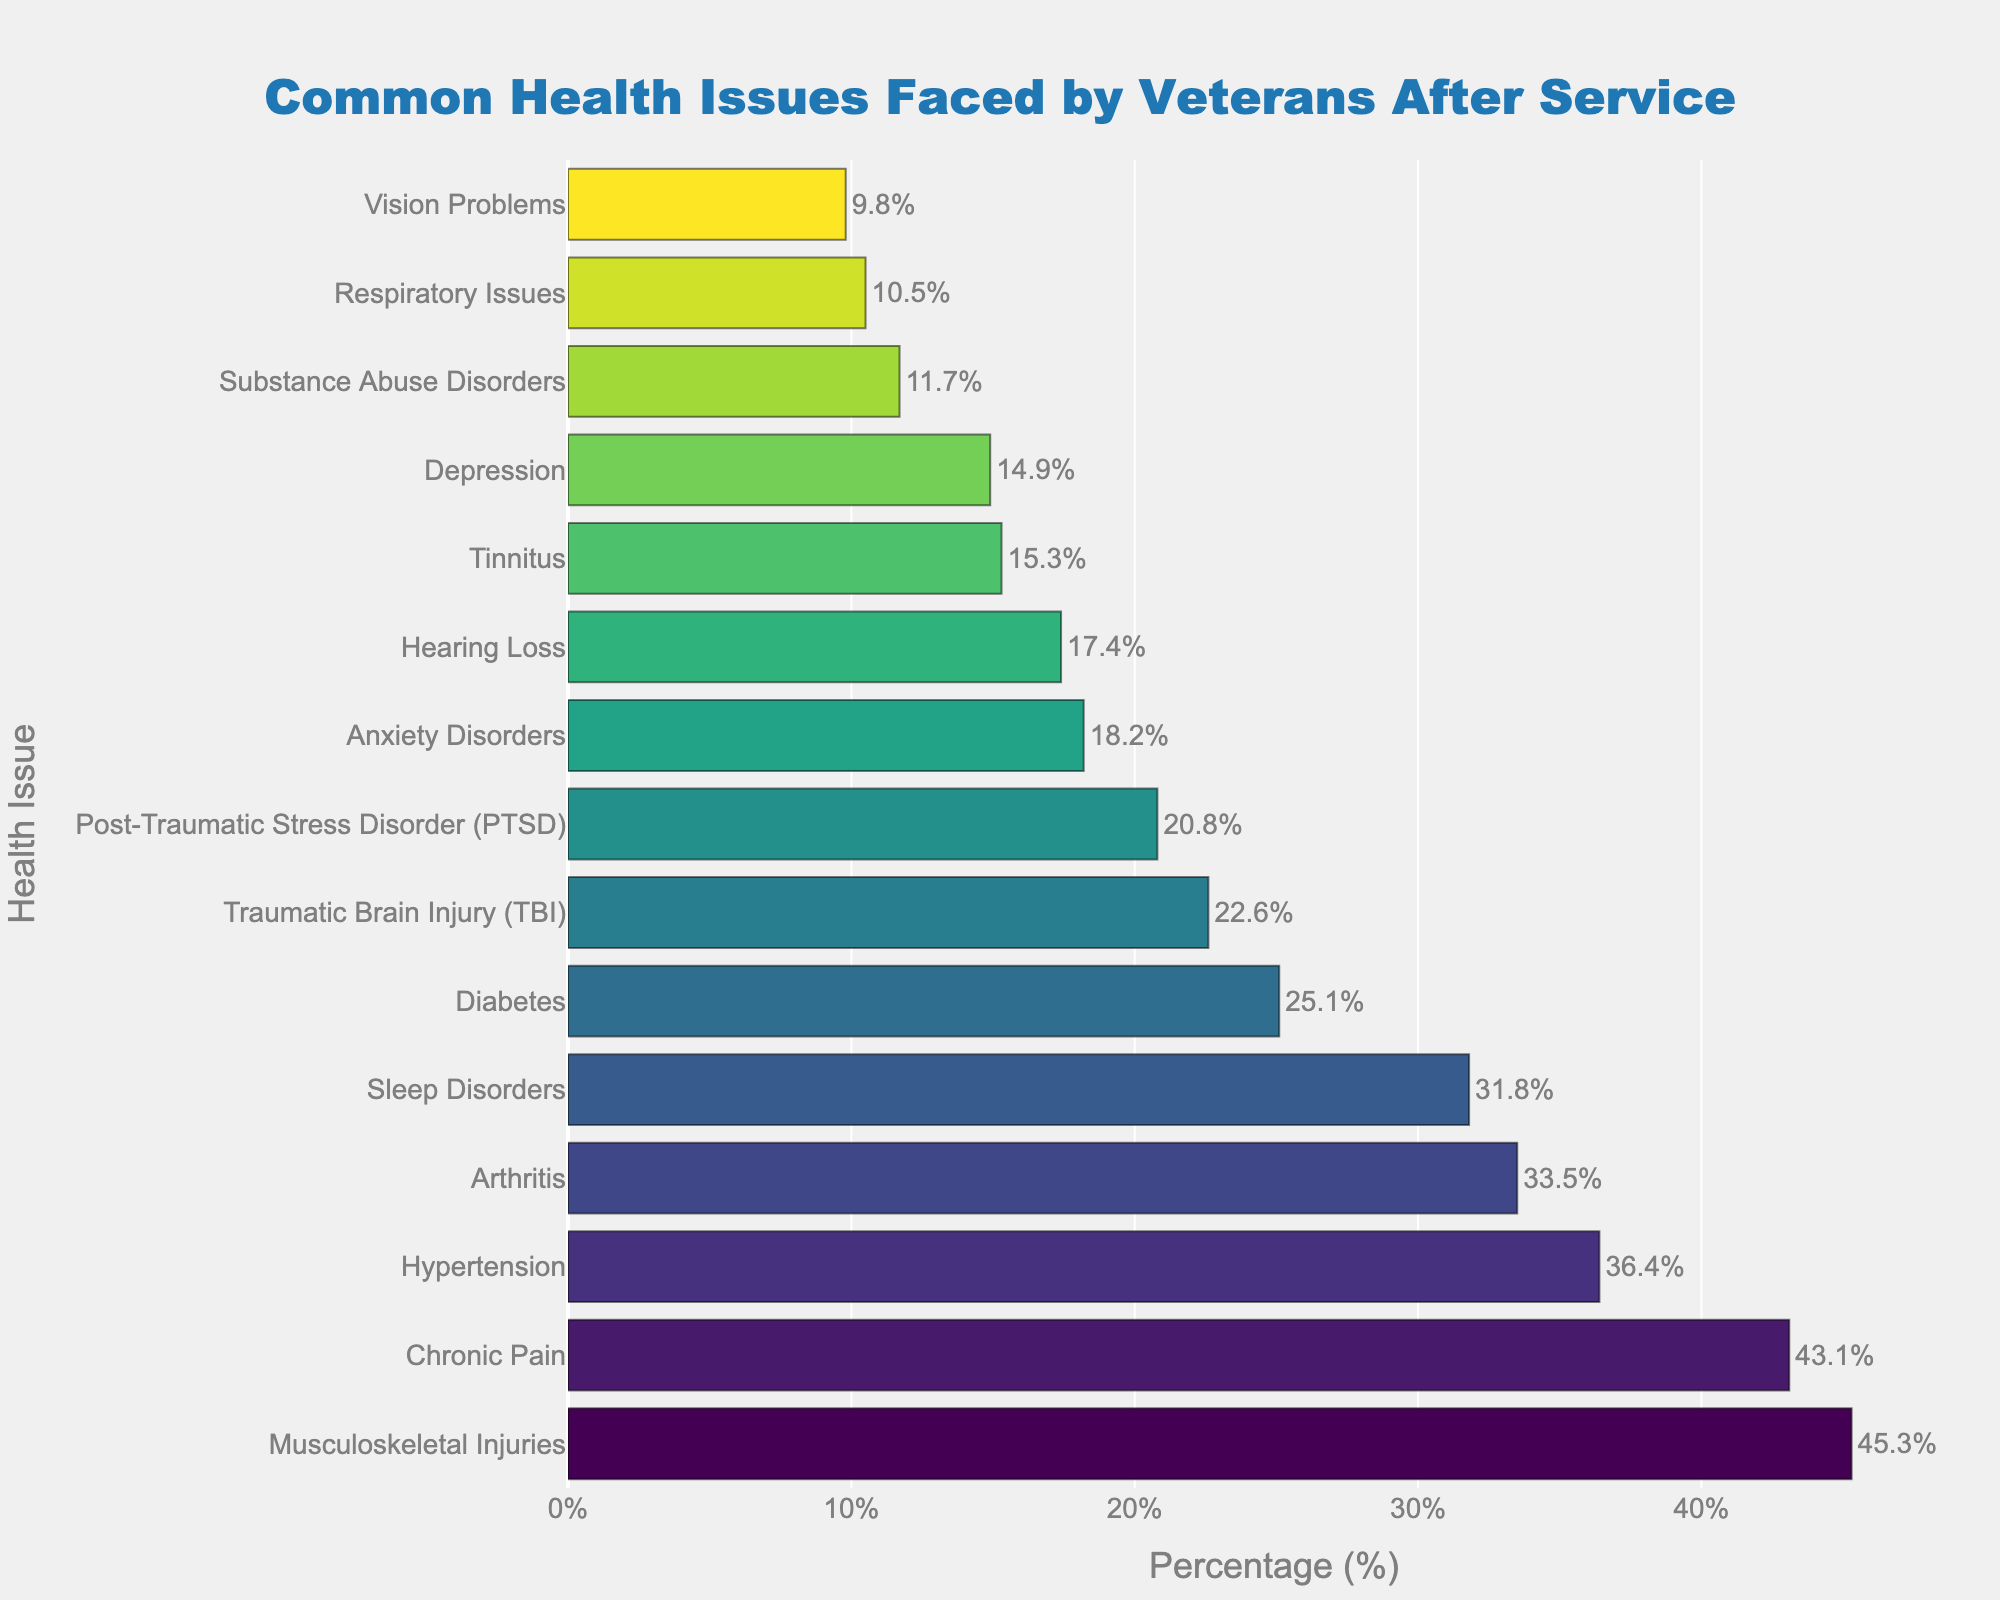Which health issue faced by veterans has the highest percentage? By visually inspecting the figure, the bar corresponding to "Musculoskeletal Injuries" is the longest, indicating it has the highest percentage.
Answer: Musculoskeletal Injuries What is the combined percentage of veterans facing Post-Traumatic Stress Disorder (PTSD) and Traumatic Brain Injury (TBI)? Sum the percentages of PTSD (20.8%) and TBI (22.6%). The combined percentage is 20.8 + 22.6 = 43.4%.
Answer: 43.4% Which health issue is more prevalent, Hypertension or Diabetes? By comparing the lengths of the bars, the bar corresponding to Hypertension is longer than the bar for Diabetes.
Answer: Hypertension List three health issues with a percentage higher than 30%. Visually inspect the figure and identify the bars. The health issues are Musculoskeletal Injuries (45.3%), Chronic Pain (43.1%), and Hypertension (36.4%).
Answer: Musculoskeletal Injuries, Chronic Pain, Hypertension What is the percentage difference between Substance Abuse Disorders and Sleep Disorders? Subtract the percentage of Substance Abuse Disorders (11.7%) from Sleep Disorders (31.8%). The difference is 31.8 - 11.7 = 20.1%.
Answer: 20.1% Which health issue has the smallest percentage and what is it? The bar corresponding to Vision Problems is the shortest, indicating it has the smallest percentage. The percentage is 9.8%.
Answer: Vision Problems, 9.8% Are Anxiety Disorders more or less common than Depression among veterans? By comparing the lengths of the bars, the bar corresponding to Depression is longer than the bar for Anxiety Disorders.
Answer: Less common How does the percentage of veterans with Arthritis compare to those with Diabetes? By inspecting the figure, the bar for Arthritis is shorter than the bar for Diabetes.
Answer: Less What is the average percentage of the top three health issues? Add the percentages of the top three issues: Musculoskeletal Injuries (45.3%), Chronic Pain (43.1%), and Hypertension (36.4%). Then divide by 3: (45.3 + 43.1 + 36.4) / 3 = 41.6%.
Answer: 41.6% Which category falls right in the middle of the sorted list by percentage, and what is the percentage? With 15 categories, the middle one is the 8th when sorted. "Sleep Disorders" is the 8th bar after sorting, with a percentage of 31.8%.
Answer: Sleep Disorders, 31.8% 